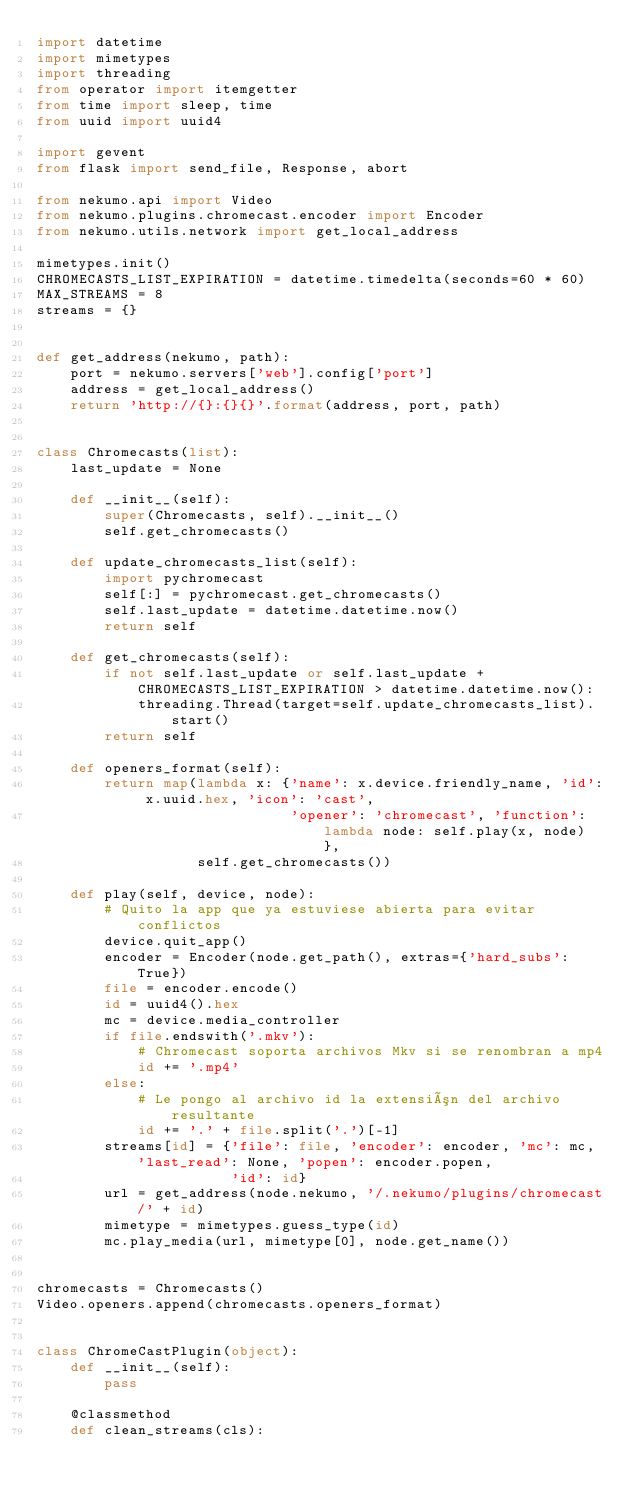Convert code to text. <code><loc_0><loc_0><loc_500><loc_500><_Python_>import datetime
import mimetypes
import threading
from operator import itemgetter
from time import sleep, time
from uuid import uuid4

import gevent
from flask import send_file, Response, abort

from nekumo.api import Video
from nekumo.plugins.chromecast.encoder import Encoder
from nekumo.utils.network import get_local_address

mimetypes.init()
CHROMECASTS_LIST_EXPIRATION = datetime.timedelta(seconds=60 * 60)
MAX_STREAMS = 8
streams = {}


def get_address(nekumo, path):
    port = nekumo.servers['web'].config['port']
    address = get_local_address()
    return 'http://{}:{}{}'.format(address, port, path)


class Chromecasts(list):
    last_update = None

    def __init__(self):
        super(Chromecasts, self).__init__()
        self.get_chromecasts()

    def update_chromecasts_list(self):
        import pychromecast
        self[:] = pychromecast.get_chromecasts()
        self.last_update = datetime.datetime.now()
        return self

    def get_chromecasts(self):
        if not self.last_update or self.last_update + CHROMECASTS_LIST_EXPIRATION > datetime.datetime.now():
            threading.Thread(target=self.update_chromecasts_list).start()
        return self

    def openers_format(self):
        return map(lambda x: {'name': x.device.friendly_name, 'id': x.uuid.hex, 'icon': 'cast',
                              'opener': 'chromecast', 'function': lambda node: self.play(x, node) },
                   self.get_chromecasts())

    def play(self, device, node):
        # Quito la app que ya estuviese abierta para evitar conflictos
        device.quit_app()
        encoder = Encoder(node.get_path(), extras={'hard_subs': True})
        file = encoder.encode()
        id = uuid4().hex
        mc = device.media_controller
        if file.endswith('.mkv'):
            # Chromecast soporta archivos Mkv si se renombran a mp4
            id += '.mp4'
        else:
            # Le pongo al archivo id la extensión del archivo resultante
            id += '.' + file.split('.')[-1]
        streams[id] = {'file': file, 'encoder': encoder, 'mc': mc, 'last_read': None, 'popen': encoder.popen,
                       'id': id}
        url = get_address(node.nekumo, '/.nekumo/plugins/chromecast/' + id)
        mimetype = mimetypes.guess_type(id)
        mc.play_media(url, mimetype[0], node.get_name())


chromecasts = Chromecasts()
Video.openers.append(chromecasts.openers_format)


class ChromeCastPlugin(object):
    def __init__(self):
        pass

    @classmethod
    def clean_streams(cls):</code> 